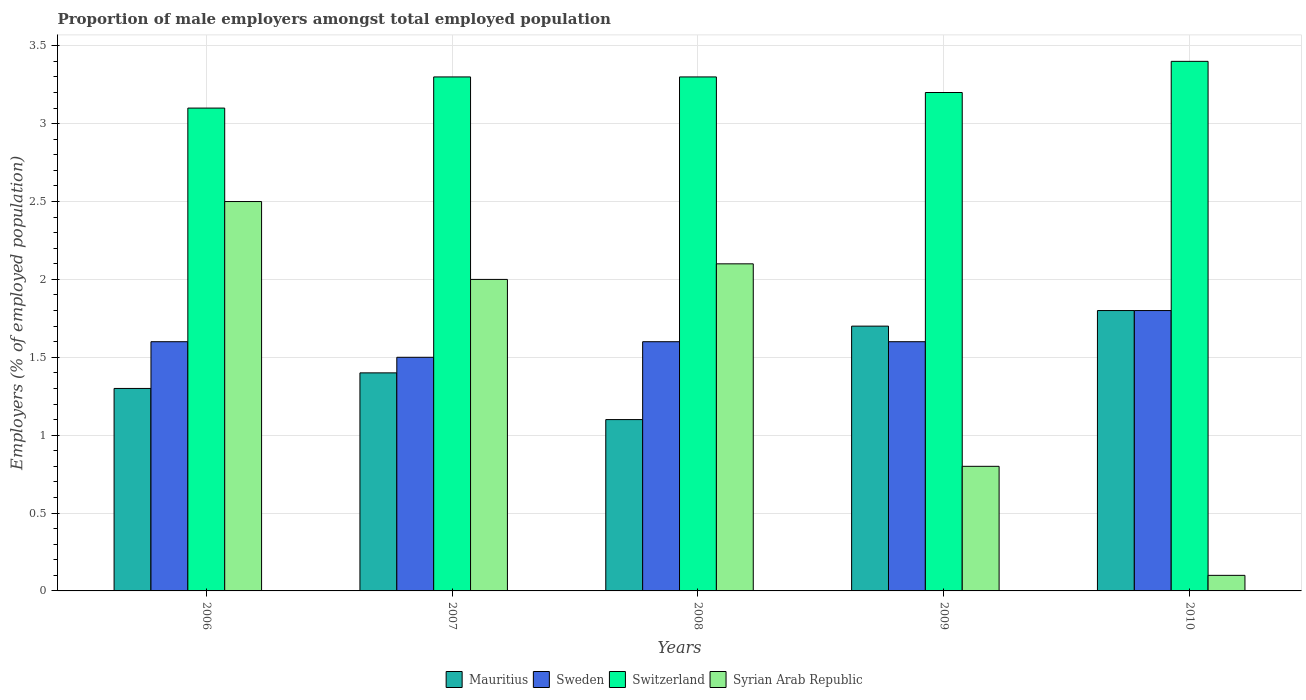How many different coloured bars are there?
Provide a succinct answer. 4. How many groups of bars are there?
Your answer should be very brief. 5. Are the number of bars per tick equal to the number of legend labels?
Make the answer very short. Yes. How many bars are there on the 2nd tick from the left?
Your response must be concise. 4. What is the proportion of male employers in Mauritius in 2009?
Offer a terse response. 1.7. Across all years, what is the minimum proportion of male employers in Switzerland?
Give a very brief answer. 3.1. In which year was the proportion of male employers in Syrian Arab Republic minimum?
Make the answer very short. 2010. What is the total proportion of male employers in Sweden in the graph?
Make the answer very short. 8.1. What is the difference between the proportion of male employers in Switzerland in 2006 and that in 2010?
Make the answer very short. -0.3. What is the difference between the proportion of male employers in Sweden in 2008 and the proportion of male employers in Mauritius in 2006?
Give a very brief answer. 0.3. What is the average proportion of male employers in Mauritius per year?
Provide a short and direct response. 1.46. In the year 2007, what is the difference between the proportion of male employers in Mauritius and proportion of male employers in Sweden?
Offer a terse response. -0.1. What is the ratio of the proportion of male employers in Mauritius in 2009 to that in 2010?
Keep it short and to the point. 0.94. Is the proportion of male employers in Switzerland in 2007 less than that in 2008?
Your answer should be very brief. No. Is the difference between the proportion of male employers in Mauritius in 2006 and 2007 greater than the difference between the proportion of male employers in Sweden in 2006 and 2007?
Provide a succinct answer. No. What is the difference between the highest and the second highest proportion of male employers in Sweden?
Your answer should be very brief. 0.2. What is the difference between the highest and the lowest proportion of male employers in Syrian Arab Republic?
Your response must be concise. 2.4. What does the 4th bar from the left in 2006 represents?
Offer a terse response. Syrian Arab Republic. How many years are there in the graph?
Your answer should be very brief. 5. What is the difference between two consecutive major ticks on the Y-axis?
Your response must be concise. 0.5. Does the graph contain any zero values?
Ensure brevity in your answer.  No. How many legend labels are there?
Provide a succinct answer. 4. How are the legend labels stacked?
Your response must be concise. Horizontal. What is the title of the graph?
Keep it short and to the point. Proportion of male employers amongst total employed population. What is the label or title of the X-axis?
Your answer should be compact. Years. What is the label or title of the Y-axis?
Offer a terse response. Employers (% of employed population). What is the Employers (% of employed population) in Mauritius in 2006?
Your response must be concise. 1.3. What is the Employers (% of employed population) of Sweden in 2006?
Make the answer very short. 1.6. What is the Employers (% of employed population) of Switzerland in 2006?
Offer a very short reply. 3.1. What is the Employers (% of employed population) of Syrian Arab Republic in 2006?
Offer a terse response. 2.5. What is the Employers (% of employed population) in Mauritius in 2007?
Your response must be concise. 1.4. What is the Employers (% of employed population) in Sweden in 2007?
Your response must be concise. 1.5. What is the Employers (% of employed population) in Switzerland in 2007?
Provide a succinct answer. 3.3. What is the Employers (% of employed population) in Syrian Arab Republic in 2007?
Give a very brief answer. 2. What is the Employers (% of employed population) in Mauritius in 2008?
Your response must be concise. 1.1. What is the Employers (% of employed population) in Sweden in 2008?
Make the answer very short. 1.6. What is the Employers (% of employed population) of Switzerland in 2008?
Your answer should be compact. 3.3. What is the Employers (% of employed population) of Syrian Arab Republic in 2008?
Offer a terse response. 2.1. What is the Employers (% of employed population) of Mauritius in 2009?
Give a very brief answer. 1.7. What is the Employers (% of employed population) of Sweden in 2009?
Your response must be concise. 1.6. What is the Employers (% of employed population) in Switzerland in 2009?
Provide a succinct answer. 3.2. What is the Employers (% of employed population) in Syrian Arab Republic in 2009?
Give a very brief answer. 0.8. What is the Employers (% of employed population) in Mauritius in 2010?
Give a very brief answer. 1.8. What is the Employers (% of employed population) in Sweden in 2010?
Provide a short and direct response. 1.8. What is the Employers (% of employed population) of Switzerland in 2010?
Keep it short and to the point. 3.4. What is the Employers (% of employed population) in Syrian Arab Republic in 2010?
Provide a succinct answer. 0.1. Across all years, what is the maximum Employers (% of employed population) in Mauritius?
Offer a very short reply. 1.8. Across all years, what is the maximum Employers (% of employed population) in Sweden?
Keep it short and to the point. 1.8. Across all years, what is the maximum Employers (% of employed population) of Switzerland?
Make the answer very short. 3.4. Across all years, what is the minimum Employers (% of employed population) in Mauritius?
Your answer should be very brief. 1.1. Across all years, what is the minimum Employers (% of employed population) in Switzerland?
Offer a terse response. 3.1. Across all years, what is the minimum Employers (% of employed population) in Syrian Arab Republic?
Give a very brief answer. 0.1. What is the total Employers (% of employed population) of Sweden in the graph?
Provide a short and direct response. 8.1. What is the total Employers (% of employed population) in Switzerland in the graph?
Keep it short and to the point. 16.3. What is the difference between the Employers (% of employed population) in Mauritius in 2006 and that in 2007?
Your response must be concise. -0.1. What is the difference between the Employers (% of employed population) in Sweden in 2006 and that in 2007?
Offer a very short reply. 0.1. What is the difference between the Employers (% of employed population) in Switzerland in 2006 and that in 2007?
Provide a short and direct response. -0.2. What is the difference between the Employers (% of employed population) of Syrian Arab Republic in 2006 and that in 2007?
Your response must be concise. 0.5. What is the difference between the Employers (% of employed population) of Switzerland in 2006 and that in 2008?
Your answer should be compact. -0.2. What is the difference between the Employers (% of employed population) of Syrian Arab Republic in 2006 and that in 2008?
Give a very brief answer. 0.4. What is the difference between the Employers (% of employed population) of Sweden in 2006 and that in 2009?
Provide a short and direct response. 0. What is the difference between the Employers (% of employed population) of Switzerland in 2006 and that in 2009?
Keep it short and to the point. -0.1. What is the difference between the Employers (% of employed population) in Syrian Arab Republic in 2006 and that in 2009?
Your response must be concise. 1.7. What is the difference between the Employers (% of employed population) in Switzerland in 2006 and that in 2010?
Your answer should be compact. -0.3. What is the difference between the Employers (% of employed population) in Syrian Arab Republic in 2006 and that in 2010?
Your answer should be compact. 2.4. What is the difference between the Employers (% of employed population) of Mauritius in 2007 and that in 2008?
Provide a short and direct response. 0.3. What is the difference between the Employers (% of employed population) of Switzerland in 2007 and that in 2008?
Provide a succinct answer. 0. What is the difference between the Employers (% of employed population) in Mauritius in 2007 and that in 2009?
Your response must be concise. -0.3. What is the difference between the Employers (% of employed population) of Sweden in 2007 and that in 2009?
Ensure brevity in your answer.  -0.1. What is the difference between the Employers (% of employed population) in Switzerland in 2007 and that in 2009?
Your response must be concise. 0.1. What is the difference between the Employers (% of employed population) in Syrian Arab Republic in 2007 and that in 2009?
Provide a short and direct response. 1.2. What is the difference between the Employers (% of employed population) in Mauritius in 2007 and that in 2010?
Your answer should be compact. -0.4. What is the difference between the Employers (% of employed population) in Sweden in 2007 and that in 2010?
Make the answer very short. -0.3. What is the difference between the Employers (% of employed population) in Switzerland in 2007 and that in 2010?
Keep it short and to the point. -0.1. What is the difference between the Employers (% of employed population) of Sweden in 2008 and that in 2009?
Give a very brief answer. 0. What is the difference between the Employers (% of employed population) of Mauritius in 2008 and that in 2010?
Give a very brief answer. -0.7. What is the difference between the Employers (% of employed population) in Switzerland in 2008 and that in 2010?
Give a very brief answer. -0.1. What is the difference between the Employers (% of employed population) of Sweden in 2009 and that in 2010?
Give a very brief answer. -0.2. What is the difference between the Employers (% of employed population) of Switzerland in 2009 and that in 2010?
Your response must be concise. -0.2. What is the difference between the Employers (% of employed population) of Mauritius in 2006 and the Employers (% of employed population) of Switzerland in 2007?
Offer a very short reply. -2. What is the difference between the Employers (% of employed population) in Mauritius in 2006 and the Employers (% of employed population) in Syrian Arab Republic in 2007?
Make the answer very short. -0.7. What is the difference between the Employers (% of employed population) of Switzerland in 2006 and the Employers (% of employed population) of Syrian Arab Republic in 2007?
Offer a terse response. 1.1. What is the difference between the Employers (% of employed population) in Mauritius in 2006 and the Employers (% of employed population) in Switzerland in 2008?
Ensure brevity in your answer.  -2. What is the difference between the Employers (% of employed population) of Mauritius in 2006 and the Employers (% of employed population) of Syrian Arab Republic in 2008?
Offer a terse response. -0.8. What is the difference between the Employers (% of employed population) of Sweden in 2006 and the Employers (% of employed population) of Switzerland in 2008?
Give a very brief answer. -1.7. What is the difference between the Employers (% of employed population) of Sweden in 2006 and the Employers (% of employed population) of Syrian Arab Republic in 2008?
Offer a terse response. -0.5. What is the difference between the Employers (% of employed population) of Switzerland in 2006 and the Employers (% of employed population) of Syrian Arab Republic in 2008?
Your answer should be compact. 1. What is the difference between the Employers (% of employed population) of Mauritius in 2006 and the Employers (% of employed population) of Sweden in 2009?
Your answer should be compact. -0.3. What is the difference between the Employers (% of employed population) in Sweden in 2006 and the Employers (% of employed population) in Switzerland in 2009?
Offer a terse response. -1.6. What is the difference between the Employers (% of employed population) of Switzerland in 2006 and the Employers (% of employed population) of Syrian Arab Republic in 2009?
Your response must be concise. 2.3. What is the difference between the Employers (% of employed population) in Mauritius in 2006 and the Employers (% of employed population) in Switzerland in 2010?
Keep it short and to the point. -2.1. What is the difference between the Employers (% of employed population) in Mauritius in 2006 and the Employers (% of employed population) in Syrian Arab Republic in 2010?
Offer a terse response. 1.2. What is the difference between the Employers (% of employed population) of Sweden in 2006 and the Employers (% of employed population) of Syrian Arab Republic in 2010?
Give a very brief answer. 1.5. What is the difference between the Employers (% of employed population) in Mauritius in 2007 and the Employers (% of employed population) in Sweden in 2008?
Your answer should be very brief. -0.2. What is the difference between the Employers (% of employed population) of Mauritius in 2007 and the Employers (% of employed population) of Syrian Arab Republic in 2008?
Offer a very short reply. -0.7. What is the difference between the Employers (% of employed population) of Sweden in 2007 and the Employers (% of employed population) of Syrian Arab Republic in 2008?
Ensure brevity in your answer.  -0.6. What is the difference between the Employers (% of employed population) in Switzerland in 2007 and the Employers (% of employed population) in Syrian Arab Republic in 2008?
Provide a succinct answer. 1.2. What is the difference between the Employers (% of employed population) in Mauritius in 2007 and the Employers (% of employed population) in Sweden in 2009?
Your response must be concise. -0.2. What is the difference between the Employers (% of employed population) of Mauritius in 2007 and the Employers (% of employed population) of Syrian Arab Republic in 2009?
Offer a very short reply. 0.6. What is the difference between the Employers (% of employed population) in Sweden in 2007 and the Employers (% of employed population) in Syrian Arab Republic in 2009?
Give a very brief answer. 0.7. What is the difference between the Employers (% of employed population) of Switzerland in 2007 and the Employers (% of employed population) of Syrian Arab Republic in 2009?
Your response must be concise. 2.5. What is the difference between the Employers (% of employed population) in Mauritius in 2007 and the Employers (% of employed population) in Syrian Arab Republic in 2010?
Your answer should be very brief. 1.3. What is the difference between the Employers (% of employed population) of Sweden in 2007 and the Employers (% of employed population) of Switzerland in 2010?
Make the answer very short. -1.9. What is the difference between the Employers (% of employed population) of Sweden in 2007 and the Employers (% of employed population) of Syrian Arab Republic in 2010?
Ensure brevity in your answer.  1.4. What is the difference between the Employers (% of employed population) of Mauritius in 2008 and the Employers (% of employed population) of Sweden in 2009?
Ensure brevity in your answer.  -0.5. What is the difference between the Employers (% of employed population) of Mauritius in 2008 and the Employers (% of employed population) of Switzerland in 2009?
Offer a very short reply. -2.1. What is the difference between the Employers (% of employed population) of Mauritius in 2008 and the Employers (% of employed population) of Syrian Arab Republic in 2009?
Your answer should be very brief. 0.3. What is the difference between the Employers (% of employed population) in Mauritius in 2008 and the Employers (% of employed population) in Switzerland in 2010?
Make the answer very short. -2.3. What is the difference between the Employers (% of employed population) in Sweden in 2008 and the Employers (% of employed population) in Switzerland in 2010?
Make the answer very short. -1.8. What is the difference between the Employers (% of employed population) of Sweden in 2008 and the Employers (% of employed population) of Syrian Arab Republic in 2010?
Your answer should be very brief. 1.5. What is the difference between the Employers (% of employed population) in Switzerland in 2008 and the Employers (% of employed population) in Syrian Arab Republic in 2010?
Give a very brief answer. 3.2. What is the difference between the Employers (% of employed population) in Mauritius in 2009 and the Employers (% of employed population) in Sweden in 2010?
Provide a short and direct response. -0.1. What is the difference between the Employers (% of employed population) of Mauritius in 2009 and the Employers (% of employed population) of Switzerland in 2010?
Your answer should be very brief. -1.7. What is the difference between the Employers (% of employed population) in Switzerland in 2009 and the Employers (% of employed population) in Syrian Arab Republic in 2010?
Give a very brief answer. 3.1. What is the average Employers (% of employed population) in Mauritius per year?
Offer a terse response. 1.46. What is the average Employers (% of employed population) of Sweden per year?
Ensure brevity in your answer.  1.62. What is the average Employers (% of employed population) in Switzerland per year?
Offer a terse response. 3.26. What is the average Employers (% of employed population) of Syrian Arab Republic per year?
Give a very brief answer. 1.5. In the year 2006, what is the difference between the Employers (% of employed population) of Mauritius and Employers (% of employed population) of Switzerland?
Offer a terse response. -1.8. In the year 2006, what is the difference between the Employers (% of employed population) in Sweden and Employers (% of employed population) in Switzerland?
Offer a very short reply. -1.5. In the year 2006, what is the difference between the Employers (% of employed population) of Sweden and Employers (% of employed population) of Syrian Arab Republic?
Your answer should be very brief. -0.9. In the year 2007, what is the difference between the Employers (% of employed population) of Mauritius and Employers (% of employed population) of Switzerland?
Offer a very short reply. -1.9. In the year 2007, what is the difference between the Employers (% of employed population) in Mauritius and Employers (% of employed population) in Syrian Arab Republic?
Provide a short and direct response. -0.6. In the year 2007, what is the difference between the Employers (% of employed population) in Switzerland and Employers (% of employed population) in Syrian Arab Republic?
Make the answer very short. 1.3. In the year 2008, what is the difference between the Employers (% of employed population) of Mauritius and Employers (% of employed population) of Sweden?
Give a very brief answer. -0.5. In the year 2008, what is the difference between the Employers (% of employed population) of Mauritius and Employers (% of employed population) of Switzerland?
Offer a very short reply. -2.2. In the year 2008, what is the difference between the Employers (% of employed population) of Mauritius and Employers (% of employed population) of Syrian Arab Republic?
Provide a succinct answer. -1. In the year 2009, what is the difference between the Employers (% of employed population) of Mauritius and Employers (% of employed population) of Sweden?
Provide a succinct answer. 0.1. In the year 2009, what is the difference between the Employers (% of employed population) of Mauritius and Employers (% of employed population) of Switzerland?
Provide a succinct answer. -1.5. In the year 2009, what is the difference between the Employers (% of employed population) in Switzerland and Employers (% of employed population) in Syrian Arab Republic?
Your answer should be very brief. 2.4. In the year 2010, what is the difference between the Employers (% of employed population) in Mauritius and Employers (% of employed population) in Sweden?
Make the answer very short. 0. In the year 2010, what is the difference between the Employers (% of employed population) in Mauritius and Employers (% of employed population) in Switzerland?
Provide a succinct answer. -1.6. In the year 2010, what is the difference between the Employers (% of employed population) in Mauritius and Employers (% of employed population) in Syrian Arab Republic?
Make the answer very short. 1.7. In the year 2010, what is the difference between the Employers (% of employed population) in Sweden and Employers (% of employed population) in Switzerland?
Your response must be concise. -1.6. In the year 2010, what is the difference between the Employers (% of employed population) in Sweden and Employers (% of employed population) in Syrian Arab Republic?
Offer a very short reply. 1.7. In the year 2010, what is the difference between the Employers (% of employed population) of Switzerland and Employers (% of employed population) of Syrian Arab Republic?
Offer a very short reply. 3.3. What is the ratio of the Employers (% of employed population) in Sweden in 2006 to that in 2007?
Offer a terse response. 1.07. What is the ratio of the Employers (% of employed population) in Switzerland in 2006 to that in 2007?
Keep it short and to the point. 0.94. What is the ratio of the Employers (% of employed population) of Mauritius in 2006 to that in 2008?
Make the answer very short. 1.18. What is the ratio of the Employers (% of employed population) in Sweden in 2006 to that in 2008?
Your answer should be compact. 1. What is the ratio of the Employers (% of employed population) in Switzerland in 2006 to that in 2008?
Make the answer very short. 0.94. What is the ratio of the Employers (% of employed population) in Syrian Arab Republic in 2006 to that in 2008?
Provide a short and direct response. 1.19. What is the ratio of the Employers (% of employed population) of Mauritius in 2006 to that in 2009?
Ensure brevity in your answer.  0.76. What is the ratio of the Employers (% of employed population) in Sweden in 2006 to that in 2009?
Offer a very short reply. 1. What is the ratio of the Employers (% of employed population) of Switzerland in 2006 to that in 2009?
Offer a very short reply. 0.97. What is the ratio of the Employers (% of employed population) of Syrian Arab Republic in 2006 to that in 2009?
Your answer should be very brief. 3.12. What is the ratio of the Employers (% of employed population) of Mauritius in 2006 to that in 2010?
Your answer should be very brief. 0.72. What is the ratio of the Employers (% of employed population) in Sweden in 2006 to that in 2010?
Your answer should be compact. 0.89. What is the ratio of the Employers (% of employed population) in Switzerland in 2006 to that in 2010?
Ensure brevity in your answer.  0.91. What is the ratio of the Employers (% of employed population) of Mauritius in 2007 to that in 2008?
Ensure brevity in your answer.  1.27. What is the ratio of the Employers (% of employed population) of Sweden in 2007 to that in 2008?
Offer a terse response. 0.94. What is the ratio of the Employers (% of employed population) of Syrian Arab Republic in 2007 to that in 2008?
Your answer should be very brief. 0.95. What is the ratio of the Employers (% of employed population) in Mauritius in 2007 to that in 2009?
Your answer should be very brief. 0.82. What is the ratio of the Employers (% of employed population) of Sweden in 2007 to that in 2009?
Offer a very short reply. 0.94. What is the ratio of the Employers (% of employed population) of Switzerland in 2007 to that in 2009?
Your answer should be very brief. 1.03. What is the ratio of the Employers (% of employed population) in Mauritius in 2007 to that in 2010?
Provide a short and direct response. 0.78. What is the ratio of the Employers (% of employed population) in Sweden in 2007 to that in 2010?
Offer a terse response. 0.83. What is the ratio of the Employers (% of employed population) of Switzerland in 2007 to that in 2010?
Provide a short and direct response. 0.97. What is the ratio of the Employers (% of employed population) of Mauritius in 2008 to that in 2009?
Your response must be concise. 0.65. What is the ratio of the Employers (% of employed population) of Switzerland in 2008 to that in 2009?
Provide a succinct answer. 1.03. What is the ratio of the Employers (% of employed population) of Syrian Arab Republic in 2008 to that in 2009?
Provide a succinct answer. 2.62. What is the ratio of the Employers (% of employed population) in Mauritius in 2008 to that in 2010?
Ensure brevity in your answer.  0.61. What is the ratio of the Employers (% of employed population) of Sweden in 2008 to that in 2010?
Your answer should be compact. 0.89. What is the ratio of the Employers (% of employed population) of Switzerland in 2008 to that in 2010?
Keep it short and to the point. 0.97. What is the ratio of the Employers (% of employed population) in Syrian Arab Republic in 2008 to that in 2010?
Your answer should be compact. 21. What is the ratio of the Employers (% of employed population) in Mauritius in 2009 to that in 2010?
Your answer should be compact. 0.94. What is the ratio of the Employers (% of employed population) in Switzerland in 2009 to that in 2010?
Your answer should be very brief. 0.94. What is the ratio of the Employers (% of employed population) of Syrian Arab Republic in 2009 to that in 2010?
Offer a terse response. 8. What is the difference between the highest and the second highest Employers (% of employed population) in Switzerland?
Give a very brief answer. 0.1. What is the difference between the highest and the lowest Employers (% of employed population) of Mauritius?
Make the answer very short. 0.7. What is the difference between the highest and the lowest Employers (% of employed population) in Sweden?
Provide a succinct answer. 0.3. 